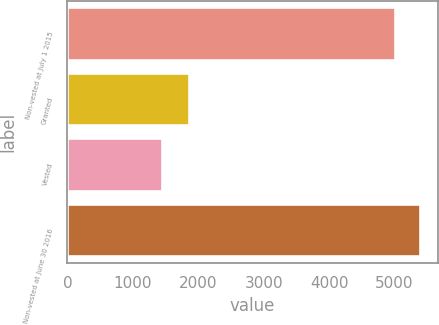Convert chart to OTSL. <chart><loc_0><loc_0><loc_500><loc_500><bar_chart><fcel>Non-vested at July 1 2015<fcel>Granted<fcel>Vested<fcel>Non-vested at June 30 2016<nl><fcel>5008<fcel>1855<fcel>1453<fcel>5390.1<nl></chart> 